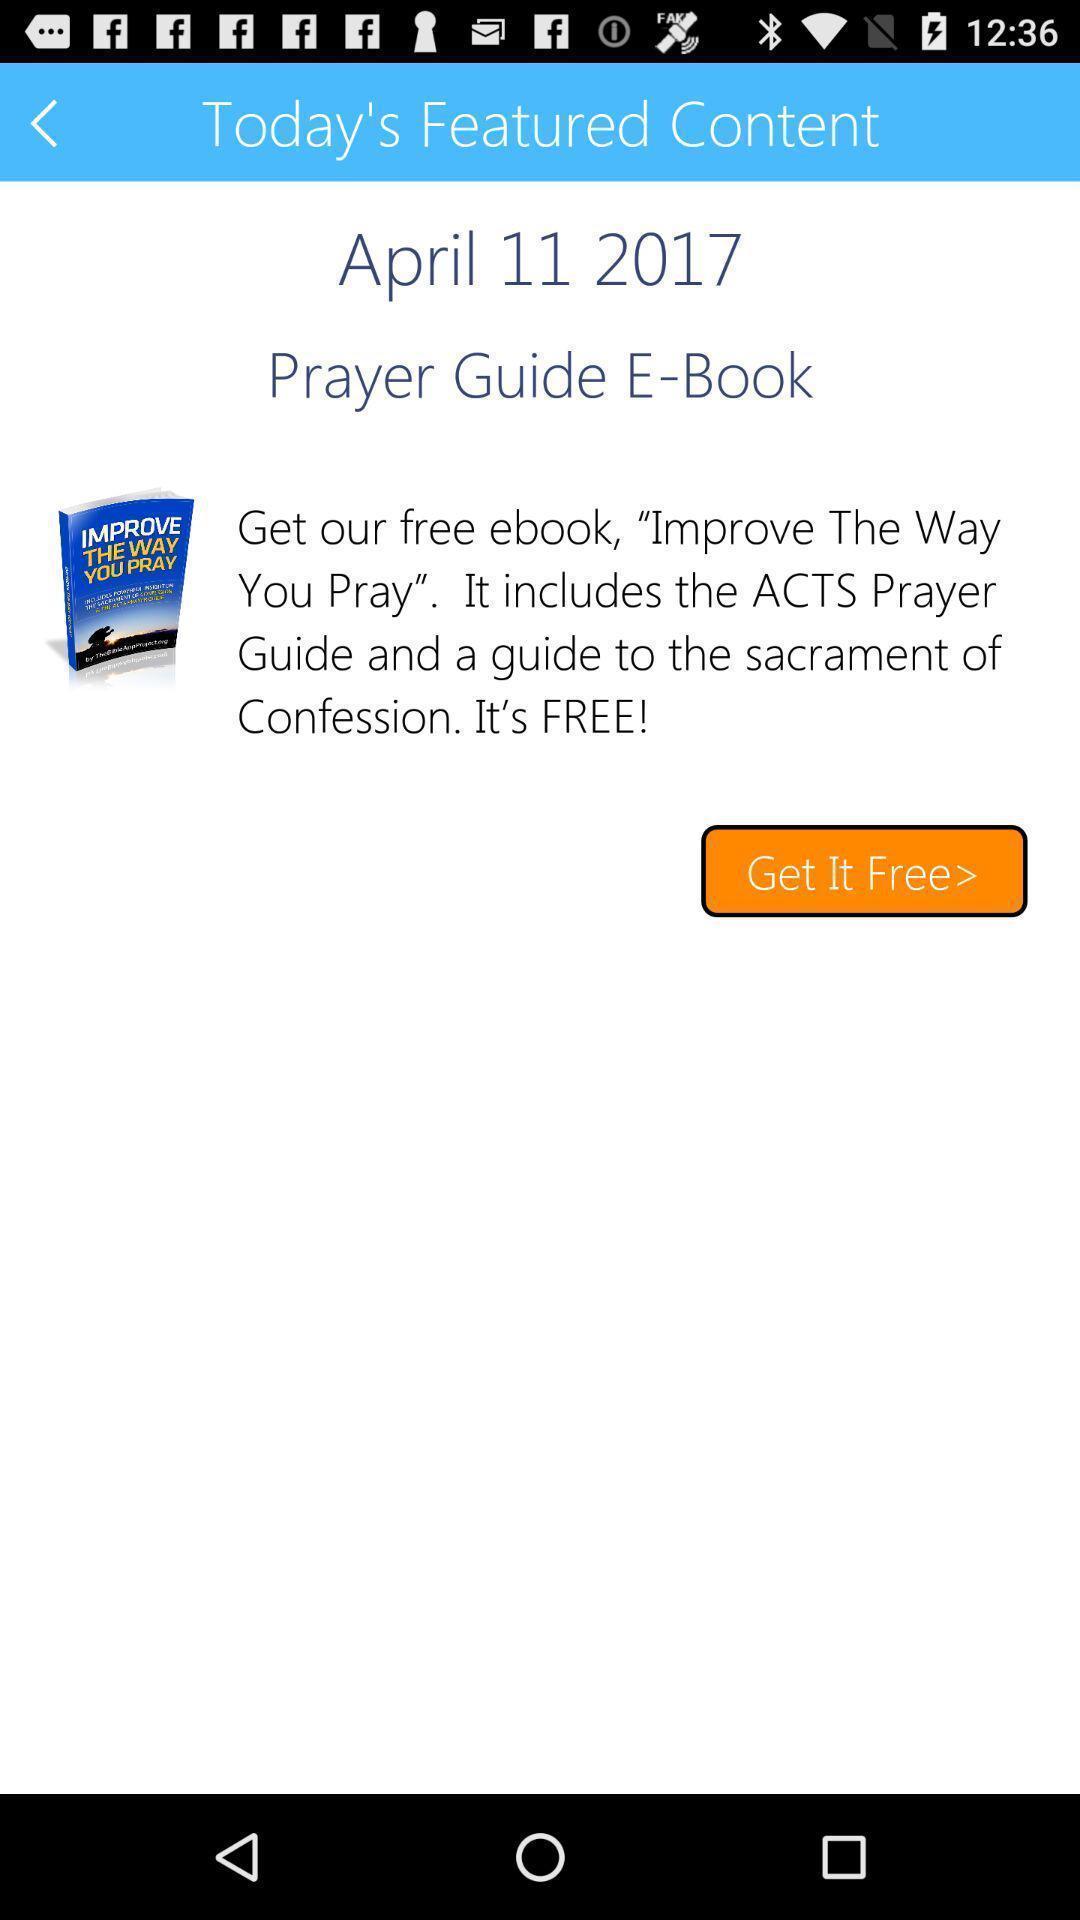Please provide a description for this image. Screen shows today 's featured content. 